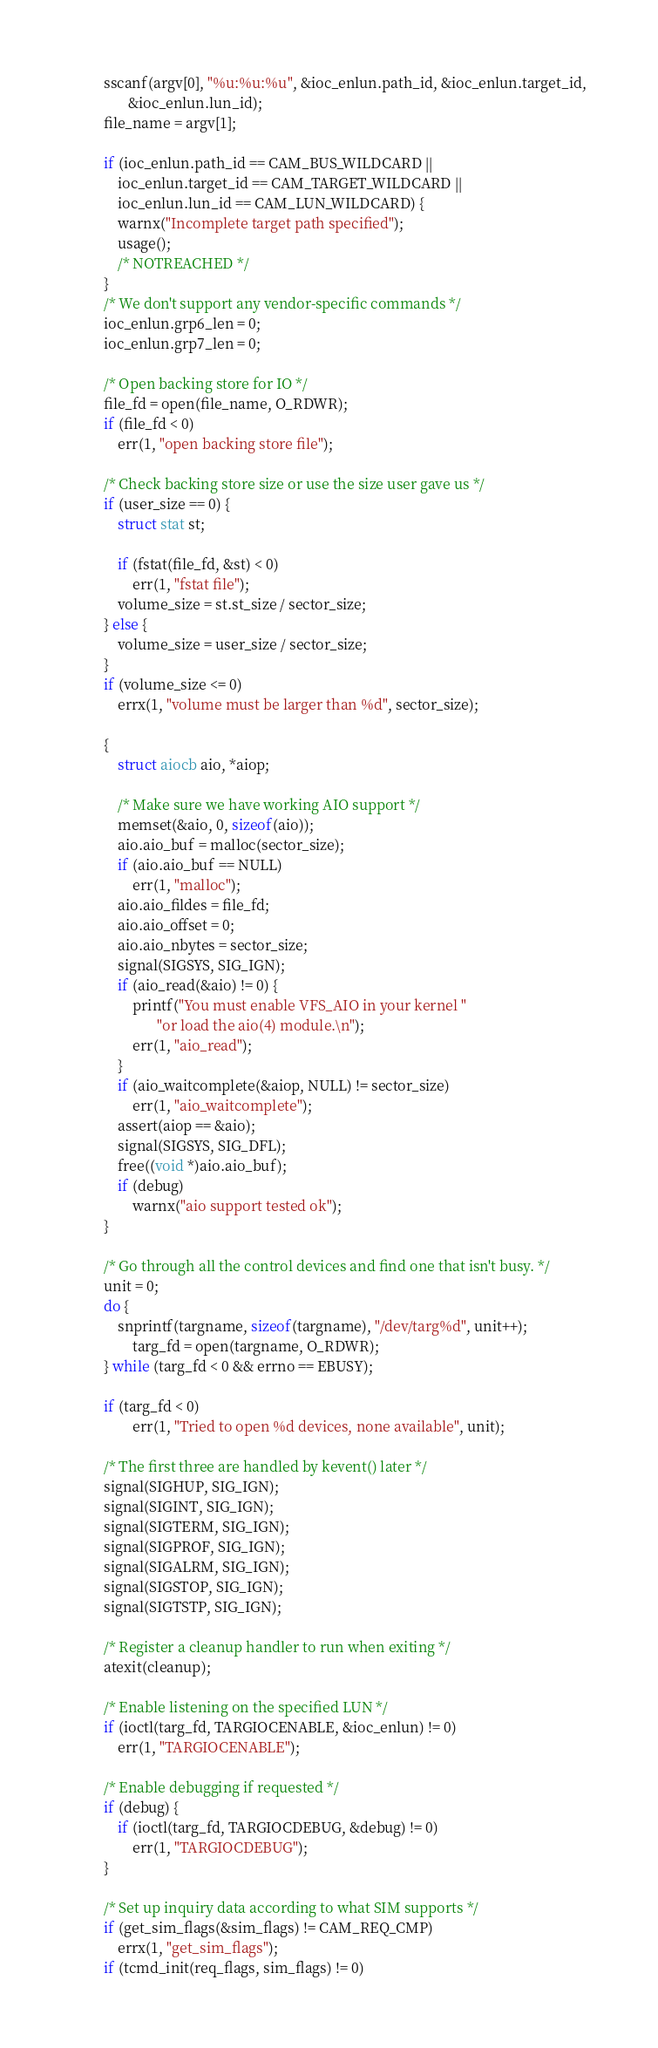<code> <loc_0><loc_0><loc_500><loc_500><_C_>	sscanf(argv[0], "%u:%u:%u", &ioc_enlun.path_id, &ioc_enlun.target_id,
	       &ioc_enlun.lun_id);
	file_name = argv[1];

	if (ioc_enlun.path_id == CAM_BUS_WILDCARD ||
	    ioc_enlun.target_id == CAM_TARGET_WILDCARD ||
	    ioc_enlun.lun_id == CAM_LUN_WILDCARD) {
		warnx("Incomplete target path specified");
		usage();
		/* NOTREACHED */
	}
	/* We don't support any vendor-specific commands */
	ioc_enlun.grp6_len = 0;
	ioc_enlun.grp7_len = 0;

	/* Open backing store for IO */
	file_fd = open(file_name, O_RDWR);
	if (file_fd < 0)
		err(1, "open backing store file");

	/* Check backing store size or use the size user gave us */
	if (user_size == 0) {
		struct stat st;

		if (fstat(file_fd, &st) < 0)
			err(1, "fstat file");
		volume_size = st.st_size / sector_size;
	} else {
		volume_size = user_size / sector_size;
	}
	if (volume_size <= 0)
		errx(1, "volume must be larger than %d", sector_size);

	{
		struct aiocb aio, *aiop;
		
		/* Make sure we have working AIO support */
		memset(&aio, 0, sizeof(aio));
		aio.aio_buf = malloc(sector_size);
		if (aio.aio_buf == NULL)
			err(1, "malloc");
		aio.aio_fildes = file_fd;
		aio.aio_offset = 0;
		aio.aio_nbytes = sector_size;
		signal(SIGSYS, SIG_IGN);
		if (aio_read(&aio) != 0) {
			printf("You must enable VFS_AIO in your kernel "
			       "or load the aio(4) module.\n");
			err(1, "aio_read");
		}
		if (aio_waitcomplete(&aiop, NULL) != sector_size)
			err(1, "aio_waitcomplete");
		assert(aiop == &aio);
		signal(SIGSYS, SIG_DFL);
		free((void *)aio.aio_buf);
		if (debug)
			warnx("aio support tested ok");
	}

	/* Go through all the control devices and find one that isn't busy. */
	unit = 0;
	do {
		snprintf(targname, sizeof(targname), "/dev/targ%d", unit++);
    		targ_fd = open(targname, O_RDWR);
	} while (targ_fd < 0 && errno == EBUSY);

	if (targ_fd < 0)
    	    err(1, "Tried to open %d devices, none available", unit);

	/* The first three are handled by kevent() later */
	signal(SIGHUP, SIG_IGN);
	signal(SIGINT, SIG_IGN);
	signal(SIGTERM, SIG_IGN);
	signal(SIGPROF, SIG_IGN);
	signal(SIGALRM, SIG_IGN);
	signal(SIGSTOP, SIG_IGN);
	signal(SIGTSTP, SIG_IGN);

	/* Register a cleanup handler to run when exiting */
	atexit(cleanup);

	/* Enable listening on the specified LUN */
	if (ioctl(targ_fd, TARGIOCENABLE, &ioc_enlun) != 0)
		err(1, "TARGIOCENABLE");

	/* Enable debugging if requested */
	if (debug) {
		if (ioctl(targ_fd, TARGIOCDEBUG, &debug) != 0)
			err(1, "TARGIOCDEBUG");
	}

	/* Set up inquiry data according to what SIM supports */
	if (get_sim_flags(&sim_flags) != CAM_REQ_CMP)
		errx(1, "get_sim_flags");
	if (tcmd_init(req_flags, sim_flags) != 0)</code> 